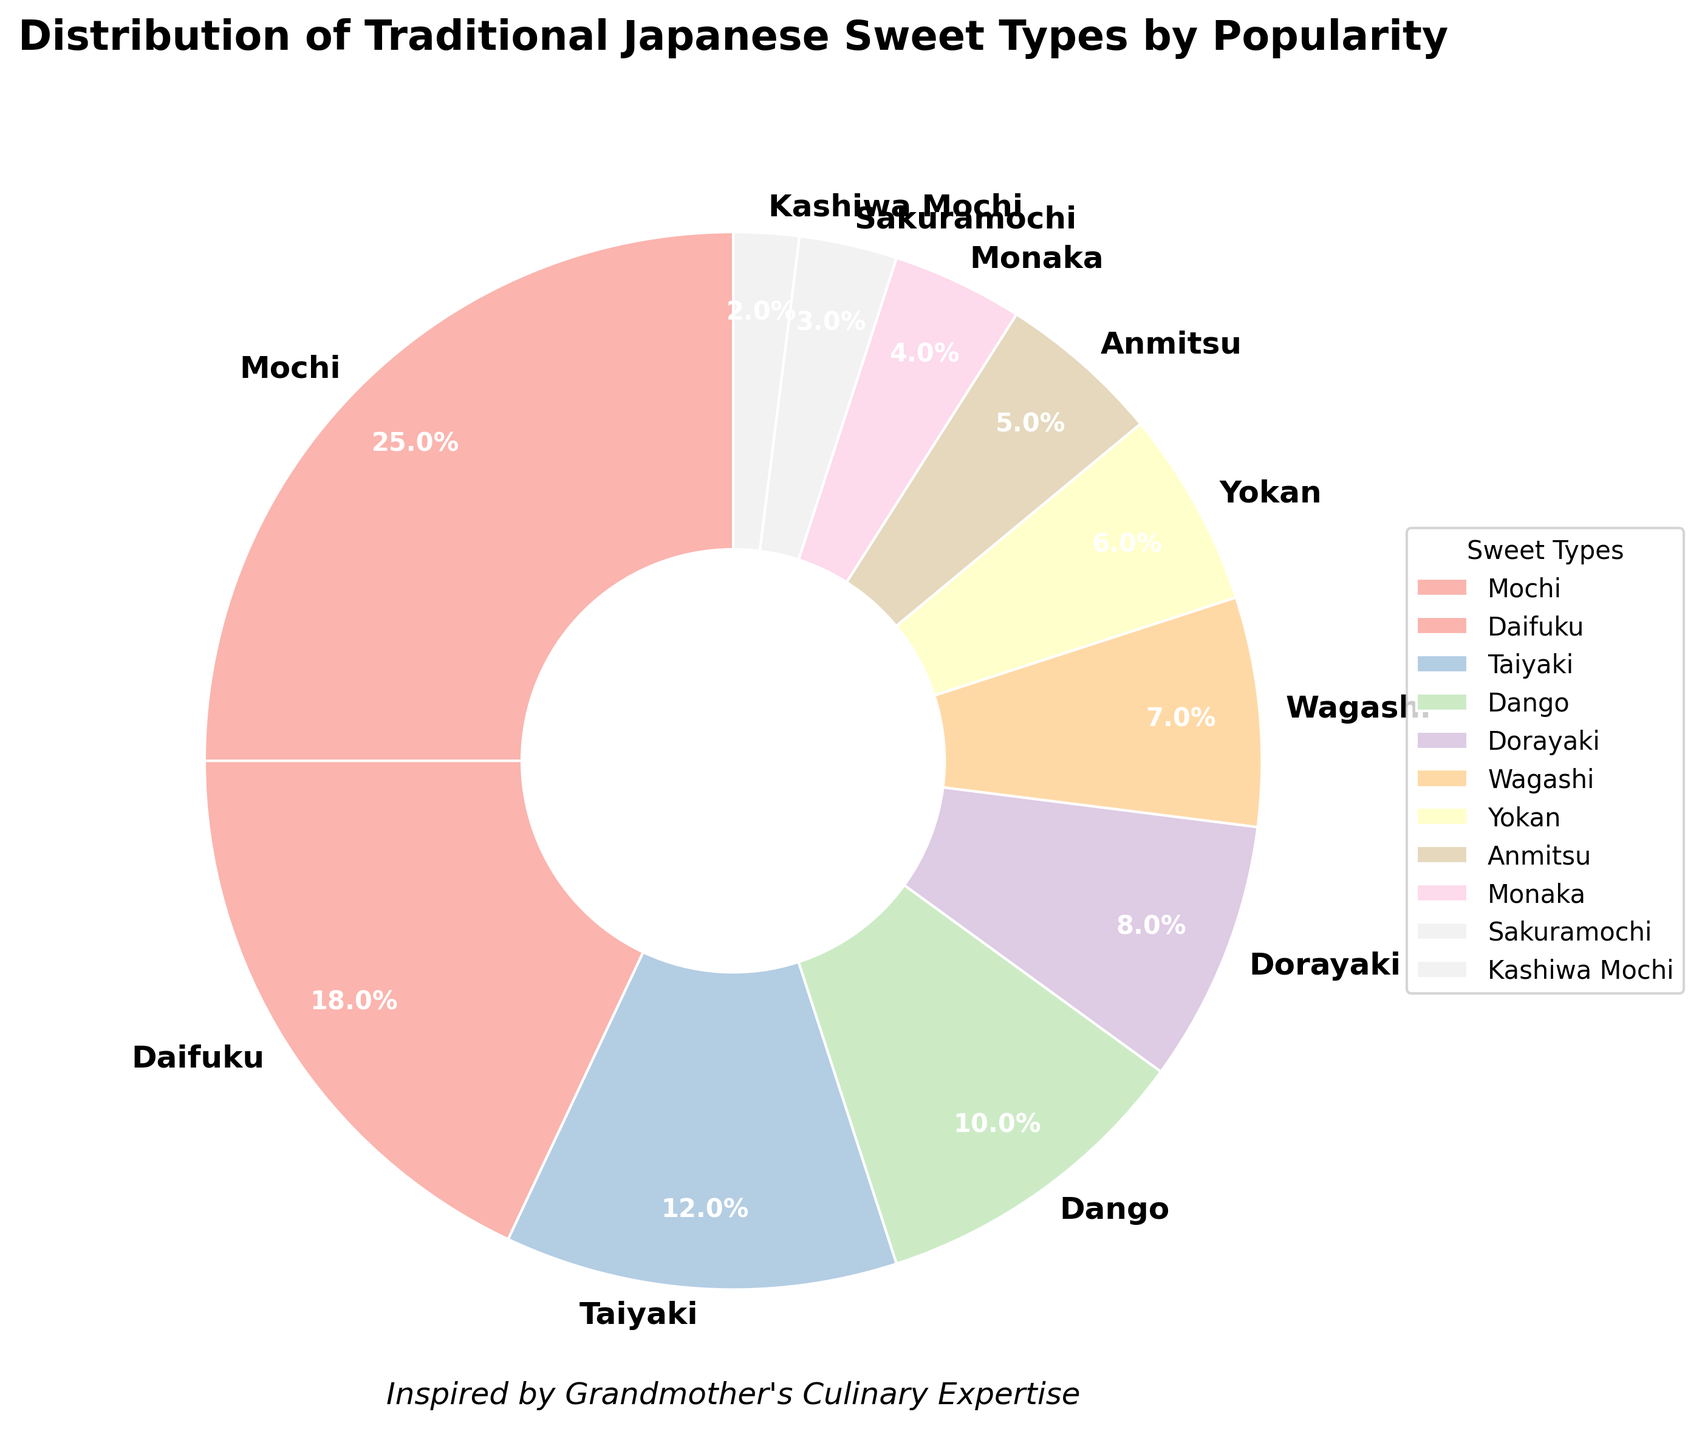What's the most popular traditional Japanese sweet type according to the figure? The pie chart shows percentages for each sweet type. Mochi holds the largest slice at 25%, making it the most popular.
Answer: Mochi Which two sweet types together make up more than 40% of the popularity? Adding the percentages of the two most popular sweet types, Mochi (25%) and Daifuku (18%), gives 43%.
Answer: Mochi and Daifuku What is the combined popularity percentage of the three least popular sweet types? Adding the percentages of Kashiwa Mochi (2%), Sakuramochi (3%), and Monaka (4%) gives 9%.
Answer: 9% Which sweet type is less popular: Wagashi or Yokan? Comparing their slices, Wagashi has 7%, whereas Yokan has 6%, making Yokan less popular.
Answer: Yokan If Taiyaki and Dango's popularity percentages are combined, what percentage do they account for? Adding Taiyaki's 12% and Dango's 10% results in 22%.
Answer: 22% How does Daifuku's popularity compare to Taiyaki’s popularity? Daifuku has 18% while Taiyaki has 12%. Therefore, Daifuku is more popular than Taiyaki.
Answer: Daifuku is more popular What is the average popularity percentage of Mochi, Daifuku, and Taiyaki combined? Summing their percentages (25% + 18% + 12%) results in 55%. Dividing by 3 gives an average of approximately 18.3%.
Answer: 18.3% What is the difference in popularity percentage between Anmitsu and Dorayaki? Dorayaki has 8% popularity, and Anmitsu has 5%. The difference is 8% - 5% = 3%.
Answer: 3% Which sweet types have a popularity percentage less than 5% and what are their names? The slices less than 5% are Anmitsu (5%), Monaka (4%), Sakuramochi (3%), and Kashiwa Mochi (2%).
Answer: Anmitsu, Monaka, Sakuramochi, and Kashiwa Mochi What visual element is used to differentiate sweet types in the pie chart? The pie chart uses different colors for each slice to represent different sweet types.
Answer: Different colors 